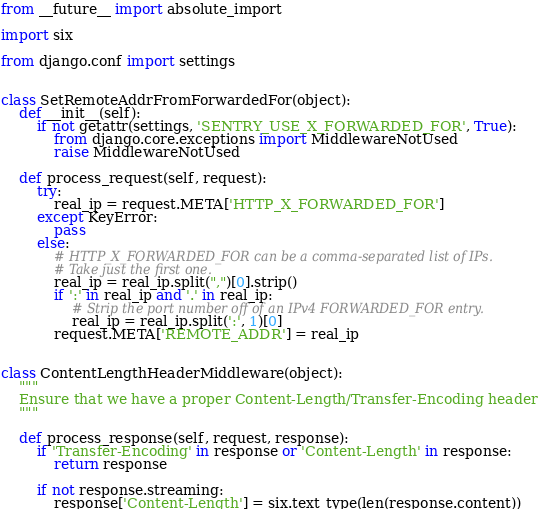<code> <loc_0><loc_0><loc_500><loc_500><_Python_>from __future__ import absolute_import

import six

from django.conf import settings


class SetRemoteAddrFromForwardedFor(object):
    def __init__(self):
        if not getattr(settings, 'SENTRY_USE_X_FORWARDED_FOR', True):
            from django.core.exceptions import MiddlewareNotUsed
            raise MiddlewareNotUsed

    def process_request(self, request):
        try:
            real_ip = request.META['HTTP_X_FORWARDED_FOR']
        except KeyError:
            pass
        else:
            # HTTP_X_FORWARDED_FOR can be a comma-separated list of IPs.
            # Take just the first one.
            real_ip = real_ip.split(",")[0].strip()
            if ':' in real_ip and '.' in real_ip:
                # Strip the port number off of an IPv4 FORWARDED_FOR entry.
                real_ip = real_ip.split(':', 1)[0]
            request.META['REMOTE_ADDR'] = real_ip


class ContentLengthHeaderMiddleware(object):
    """
    Ensure that we have a proper Content-Length/Transfer-Encoding header
    """

    def process_response(self, request, response):
        if 'Transfer-Encoding' in response or 'Content-Length' in response:
            return response

        if not response.streaming:
            response['Content-Length'] = six.text_type(len(response.content))
</code> 